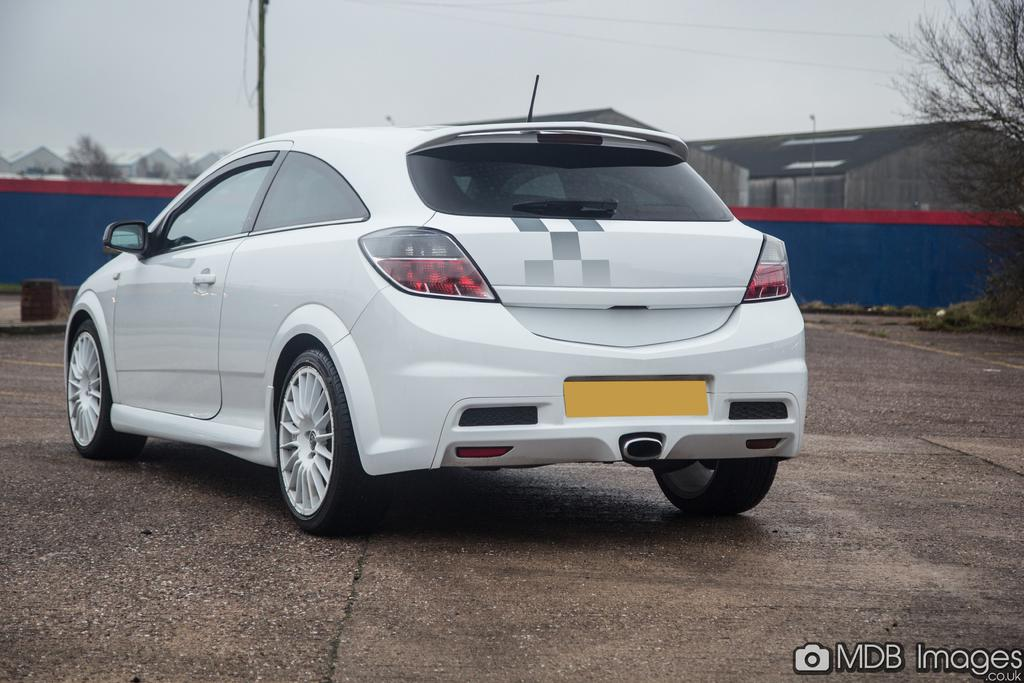What is the main subject of the image? There is a car in the image. Where is the car located? The car is on the road. What can be seen in the background of the image? There are buildings, a wall, the sky, and a tree in the background of the image. What type of butter is being used to grease the gate in the image? There is no gate or butter present in the image. Is the doctor in the image performing a checkup on the car? There is no doctor or indication of a checkup in the image; it simply shows a car on the road with a background of buildings, a wall, the sky, and a tree. 